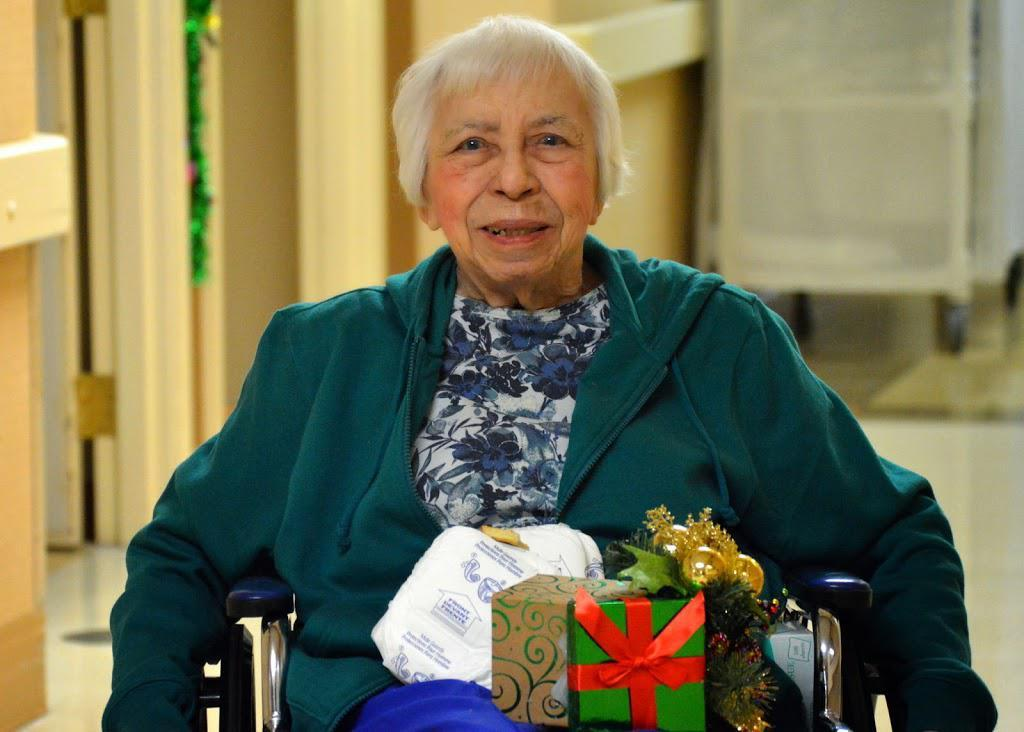What is the lady in the image sitting on? The lady is sitting on a wheelchair in the image. What is on the lady in the image? The lady has gifts on her. What can be seen on the surface in front of the lady? There are papers visible in the image. What is behind the lady in the image? There is a wall behind the lady. What is in the background of the image? There is a table in the background of the image. How would you describe the background of the image? The background of the image is blurred. What type of account does the duck in the image have? There is no duck present in the image, so it is not possible to determine if it has an account or not. 